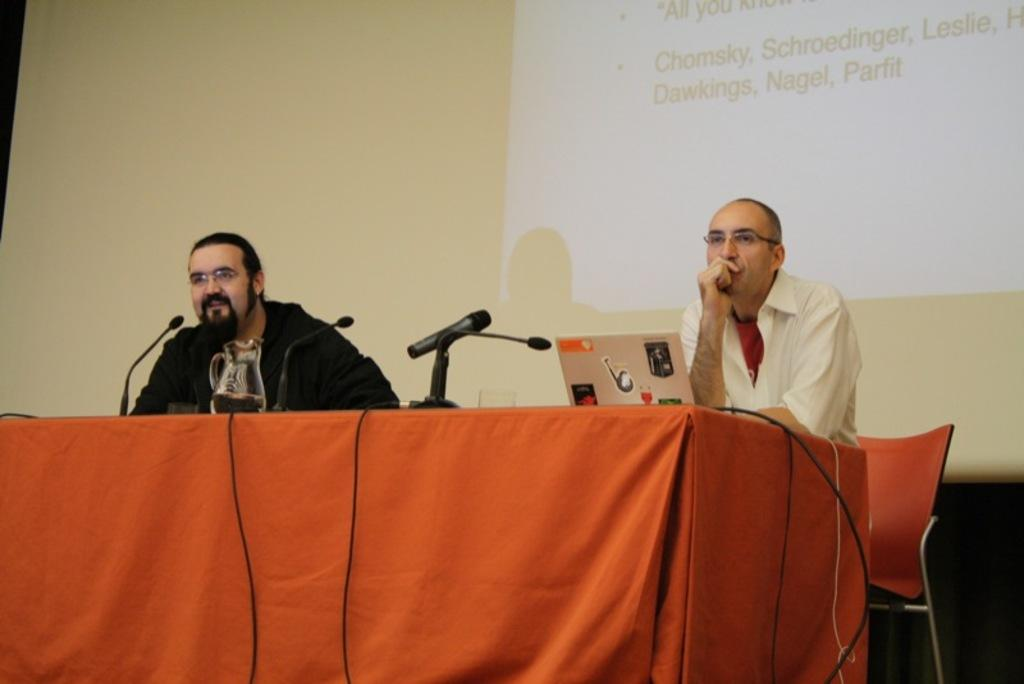How many people are sitting on the chair in the image? There are two persons sitting on a chair in the image. What object is placed on the table? A laptop is placed on the table in the image. What other items can be seen on the table? Microphones are present on the table in the image. What is the large, flat surface in the image? There is a projector screen in the image. What type of statement can be heard from the sleet in the image? There is no sleet present in the image, and therefore no statement can be heard from it. 